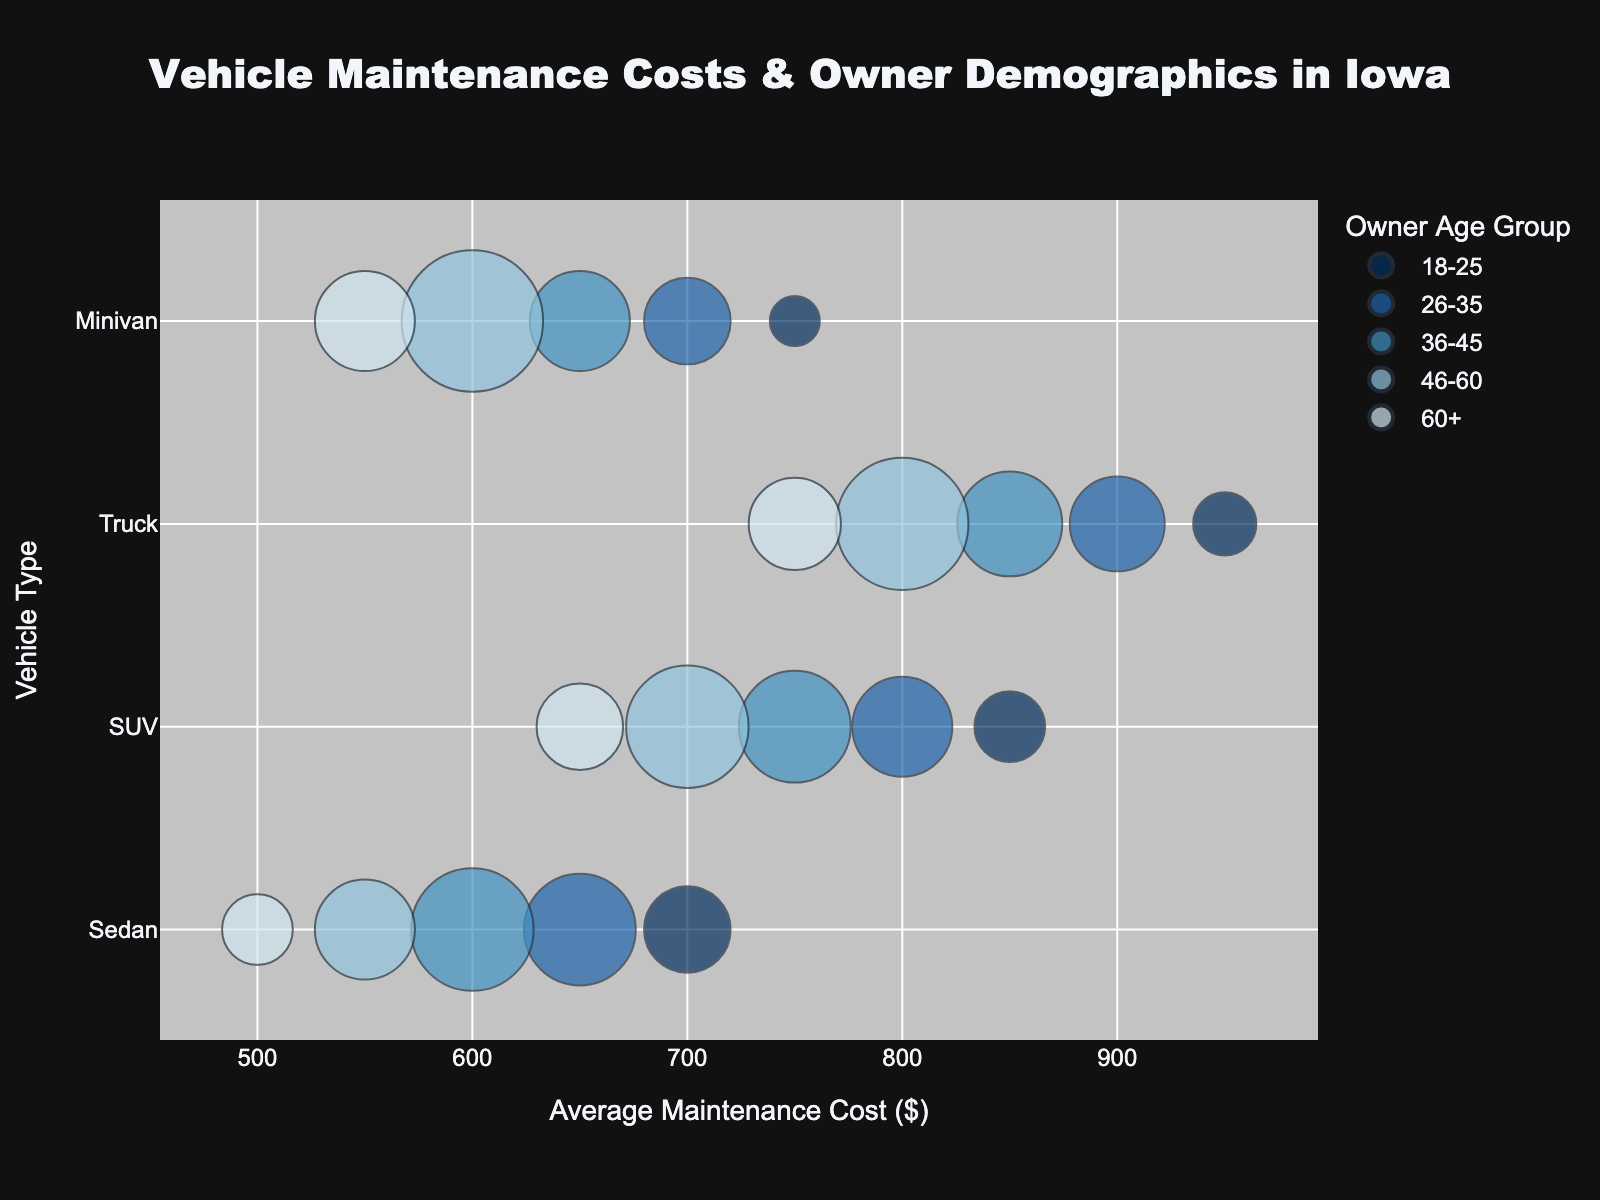What is the title of the figure? The title is usually displayed at the top of the figure. In this case, it states "Vehicle Maintenance Costs & Owner Demographics in Iowa".
Answer: Vehicle Maintenance Costs & Owner Demographics in Iowa What is the average maintenance cost range for Minivans? By observing the x-axis and the points corresponding to Minivans, we see that the average maintenance costs for Minivans range between $550 and $750.
Answer: $550 - $750 Which age group constitutes the largest percentage of owners for Trucks? The size of the bubbles indicates the percentage of owners. For Trucks, the largest bubble size is for the 46-60 age group.
Answer: 46-60 age group Among all the vehicle types, which vehicle type has the highest average maintenance cost and for which age group? The highest point on the x-axis represents the highest average maintenance cost. By looking at the bubble farthest to the right, we see that Trucks have the highest average maintenance cost in the 18-25 age group.
Answer: Trucks, 18-25 age group How do the maintenance costs compare between Sedans and SUVs for the 36-45 age group? By comparing the x-positions of the bubbles for Sedans and SUVs in the 36-45 age group (both marked with the same color), we see that SUVs have a higher average maintenance cost compared to Sedans.
Answer: SUVs have higher costs Which vehicle type has the smallest percentage of owners in the 18-25 age group? Since the bubble size indicates the percentage of owners, and Minivans have the smallest bubble size in the 18-25 age group, Minivans have the smallest percentage of owners in that group.
Answer: Minivans What is the average maintenance cost difference between Trucks and Sedans for the 46-60 age group? To find the difference, subtract the cost for Sedans from the cost for Trucks in the 46-60 age group. For Trucks, it's $800, and for Sedans, it's $550. The difference is $800 - $550 = $250.
Answer: $250 What is the approximate average maintenance cost for SUVs for all age groups combined? To estimate the average maintenance cost for SUVs across all age groups, we can consider the positions of the bubbles for SUVs along the x-axis and calculate an approximate mean. It would be around (850 + 800 + 750 + 700 + 650) / 5 = 750.
Answer: $750 Which vehicle type has the closest average maintenance cost across all age groups? By observing the spread of points along the x-axis for each vehicle type, we can see that Minivans have the average maintenance cost points most closely grouped around $650 to $750, indicating the least variation.
Answer: Minivans 